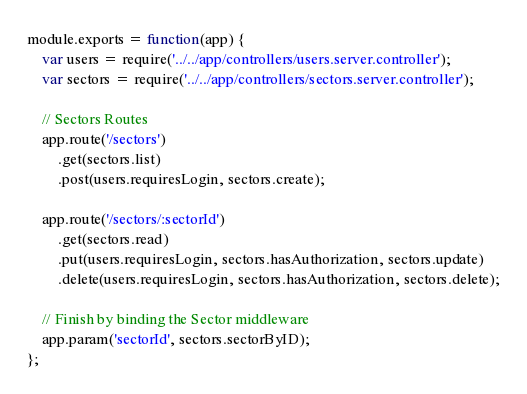<code> <loc_0><loc_0><loc_500><loc_500><_JavaScript_>
module.exports = function(app) {
	var users = require('../../app/controllers/users.server.controller');
	var sectors = require('../../app/controllers/sectors.server.controller');

	// Sectors Routes
	app.route('/sectors')
		.get(sectors.list)
		.post(users.requiresLogin, sectors.create);

	app.route('/sectors/:sectorId')
		.get(sectors.read)
		.put(users.requiresLogin, sectors.hasAuthorization, sectors.update)
		.delete(users.requiresLogin, sectors.hasAuthorization, sectors.delete);

	// Finish by binding the Sector middleware
	app.param('sectorId', sectors.sectorByID);
};
</code> 